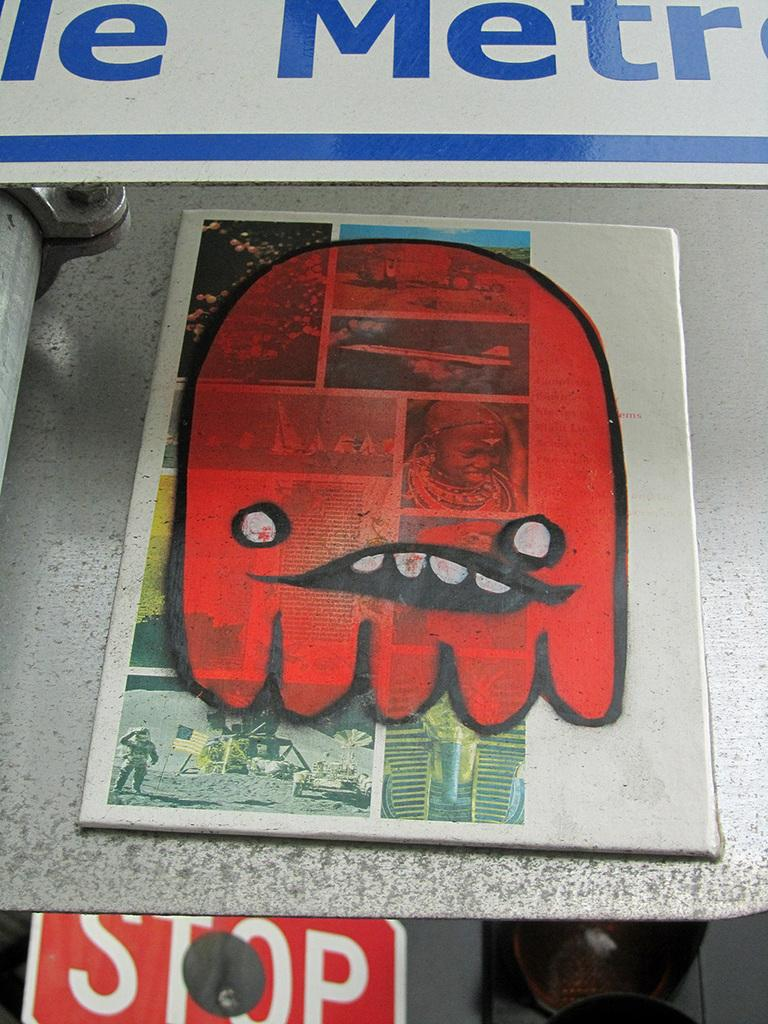<image>
Share a concise interpretation of the image provided. A spray painted red face over a stop sign. 